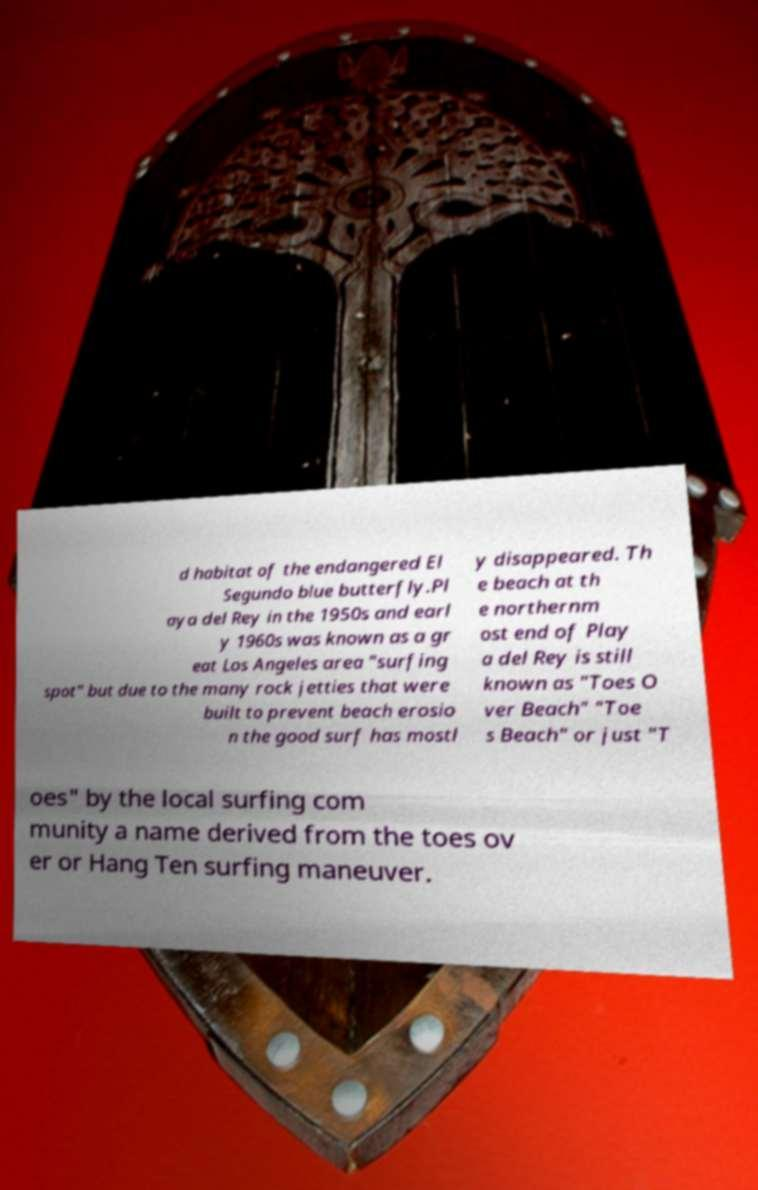For documentation purposes, I need the text within this image transcribed. Could you provide that? d habitat of the endangered El Segundo blue butterfly.Pl aya del Rey in the 1950s and earl y 1960s was known as a gr eat Los Angeles area "surfing spot" but due to the many rock jetties that were built to prevent beach erosio n the good surf has mostl y disappeared. Th e beach at th e northernm ost end of Play a del Rey is still known as "Toes O ver Beach" "Toe s Beach" or just "T oes" by the local surfing com munity a name derived from the toes ov er or Hang Ten surfing maneuver. 